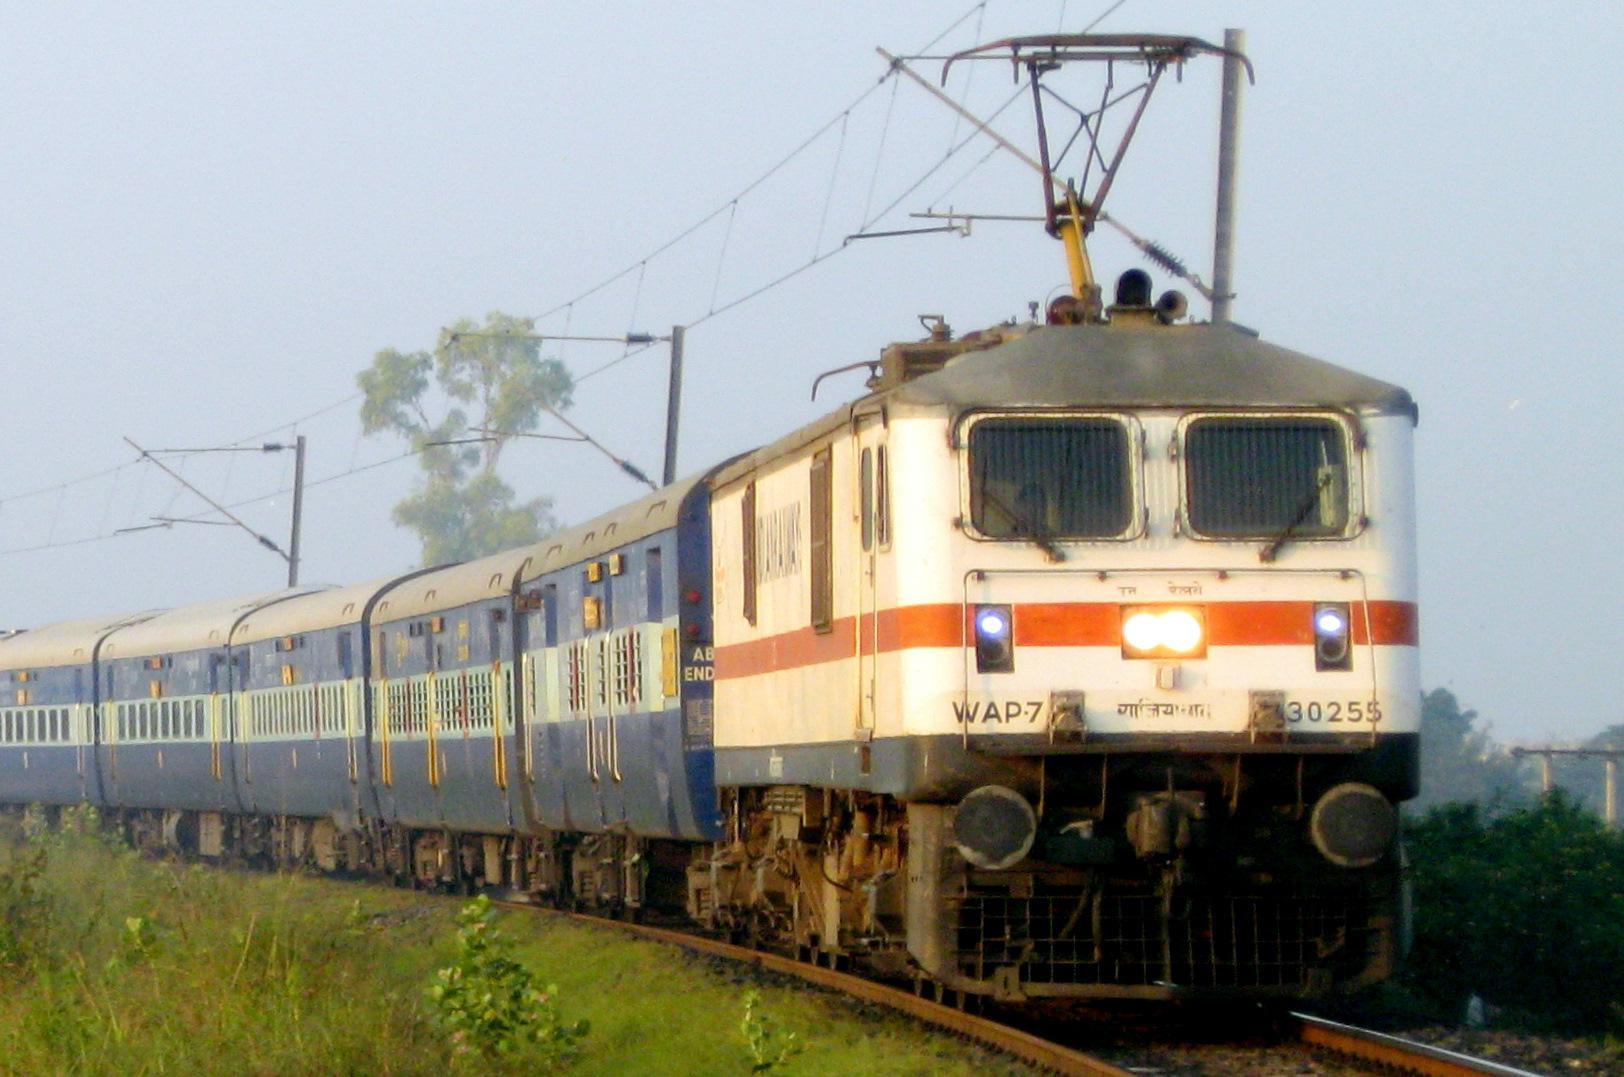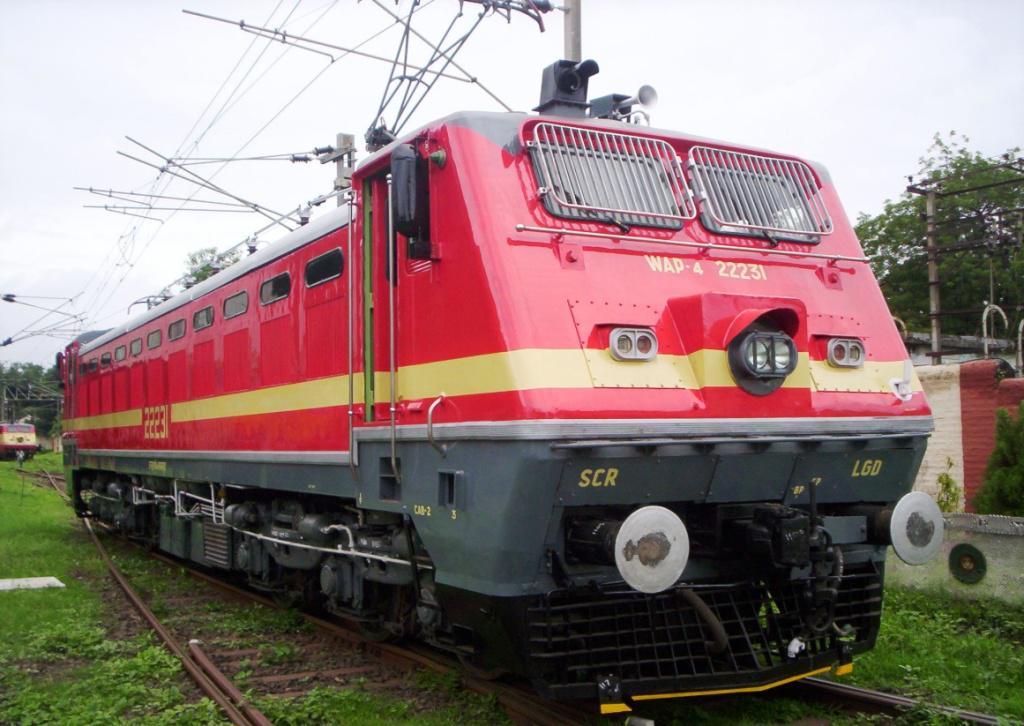The first image is the image on the left, the second image is the image on the right. For the images shown, is this caption "A train in one image is red with two grated windows on the front and a narrow yellow band encircling the car." true? Answer yes or no. Yes. 